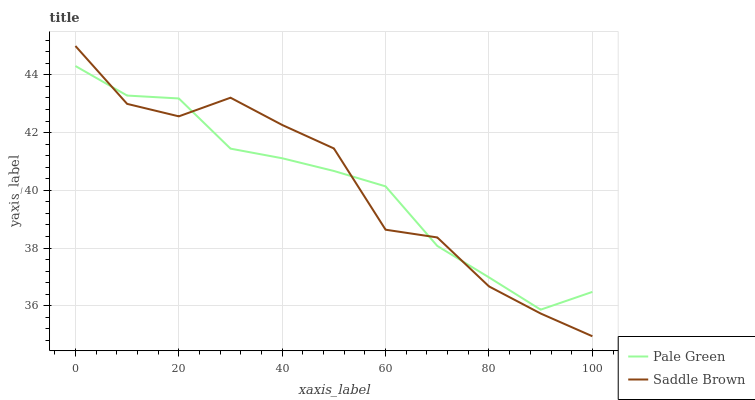Does Pale Green have the minimum area under the curve?
Answer yes or no. Yes. Does Saddle Brown have the maximum area under the curve?
Answer yes or no. Yes. Does Saddle Brown have the minimum area under the curve?
Answer yes or no. No. Is Pale Green the smoothest?
Answer yes or no. Yes. Is Saddle Brown the roughest?
Answer yes or no. Yes. Is Saddle Brown the smoothest?
Answer yes or no. No. Does Saddle Brown have the lowest value?
Answer yes or no. Yes. Does Saddle Brown have the highest value?
Answer yes or no. Yes. Does Pale Green intersect Saddle Brown?
Answer yes or no. Yes. Is Pale Green less than Saddle Brown?
Answer yes or no. No. Is Pale Green greater than Saddle Brown?
Answer yes or no. No. 